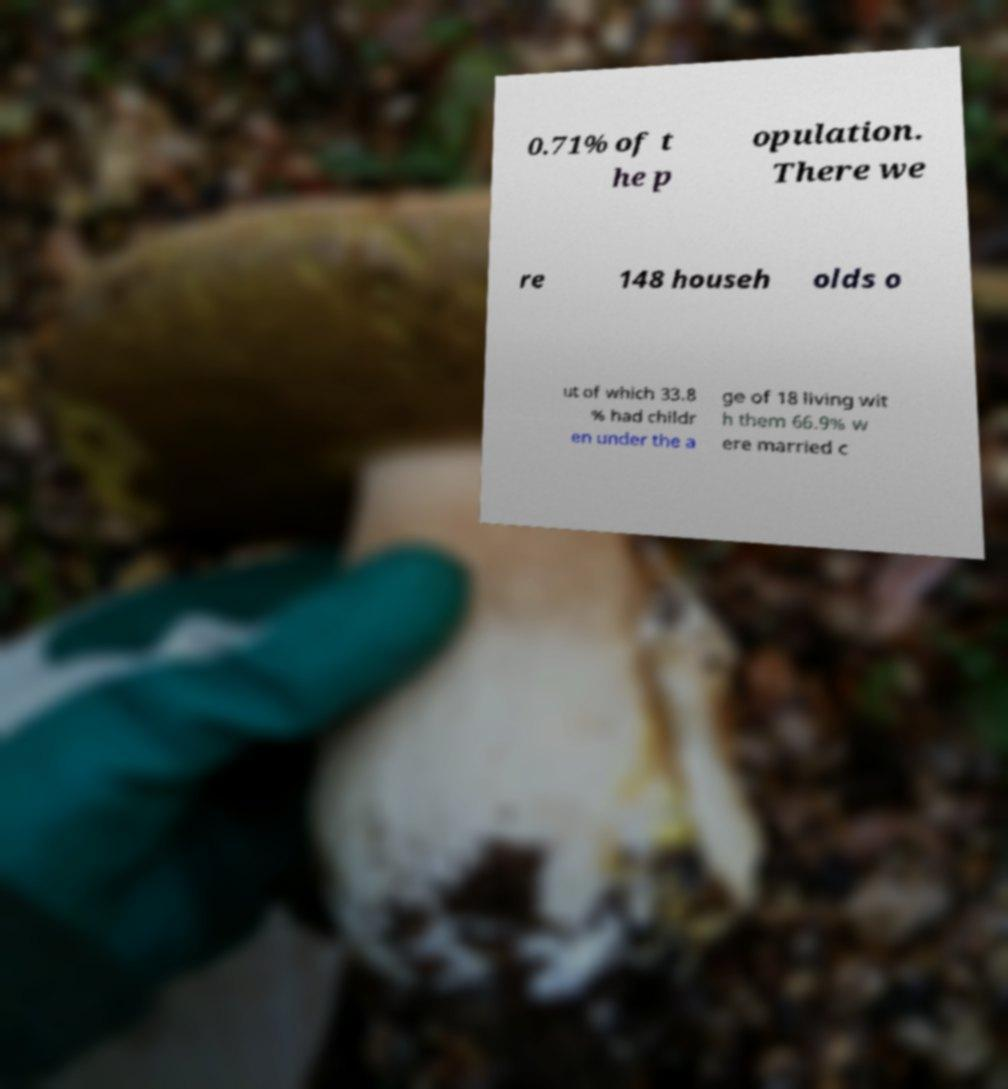Could you extract and type out the text from this image? 0.71% of t he p opulation. There we re 148 househ olds o ut of which 33.8 % had childr en under the a ge of 18 living wit h them 66.9% w ere married c 